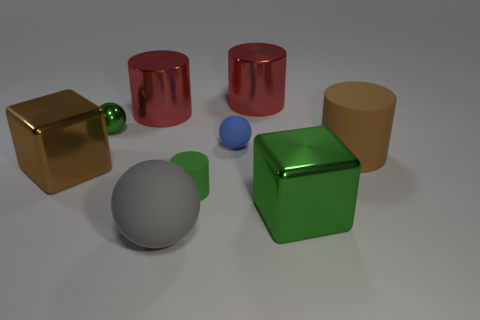What material is the blue object?
Provide a succinct answer. Rubber. There is a large green metallic cube; are there any metallic objects in front of it?
Provide a succinct answer. No. There is a shiny object that is the same shape as the blue matte thing; what is its size?
Your response must be concise. Small. Are there an equal number of tiny things that are behind the small metal sphere and big gray matte balls to the left of the gray rubber sphere?
Provide a short and direct response. Yes. How many big balls are there?
Your response must be concise. 1. Is the number of large cylinders to the right of the small blue thing greater than the number of large red cylinders?
Give a very brief answer. No. There is a big sphere that is in front of the blue thing; what is it made of?
Your answer should be compact. Rubber. The tiny thing that is the same shape as the large brown matte object is what color?
Give a very brief answer. Green. What number of tiny matte things have the same color as the large sphere?
Give a very brief answer. 0. Does the matte ball to the left of the small blue matte ball have the same size as the rubber cylinder on the right side of the tiny blue sphere?
Keep it short and to the point. Yes. 